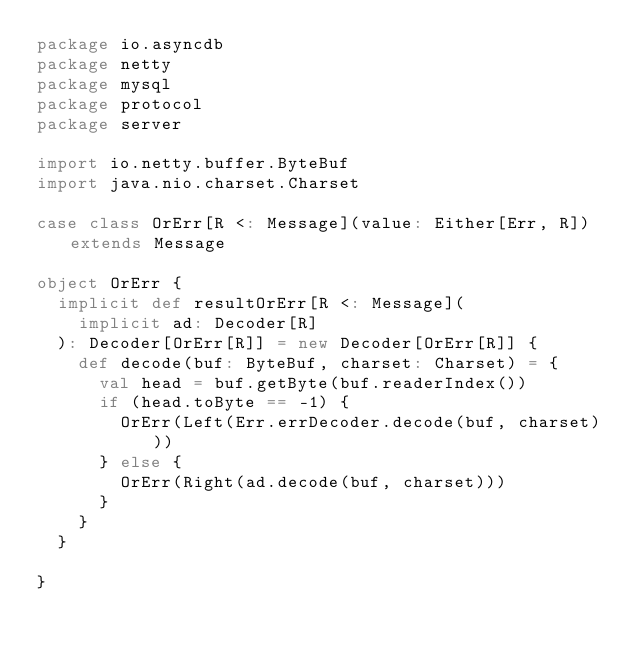<code> <loc_0><loc_0><loc_500><loc_500><_Scala_>package io.asyncdb
package netty
package mysql
package protocol
package server

import io.netty.buffer.ByteBuf
import java.nio.charset.Charset

case class OrErr[R <: Message](value: Either[Err, R]) extends Message

object OrErr {
  implicit def resultOrErr[R <: Message](
    implicit ad: Decoder[R]
  ): Decoder[OrErr[R]] = new Decoder[OrErr[R]] {
    def decode(buf: ByteBuf, charset: Charset) = {
      val head = buf.getByte(buf.readerIndex())
      if (head.toByte == -1) {
        OrErr(Left(Err.errDecoder.decode(buf, charset)))
      } else {
        OrErr(Right(ad.decode(buf, charset)))
      }
    }
  }

}
</code> 